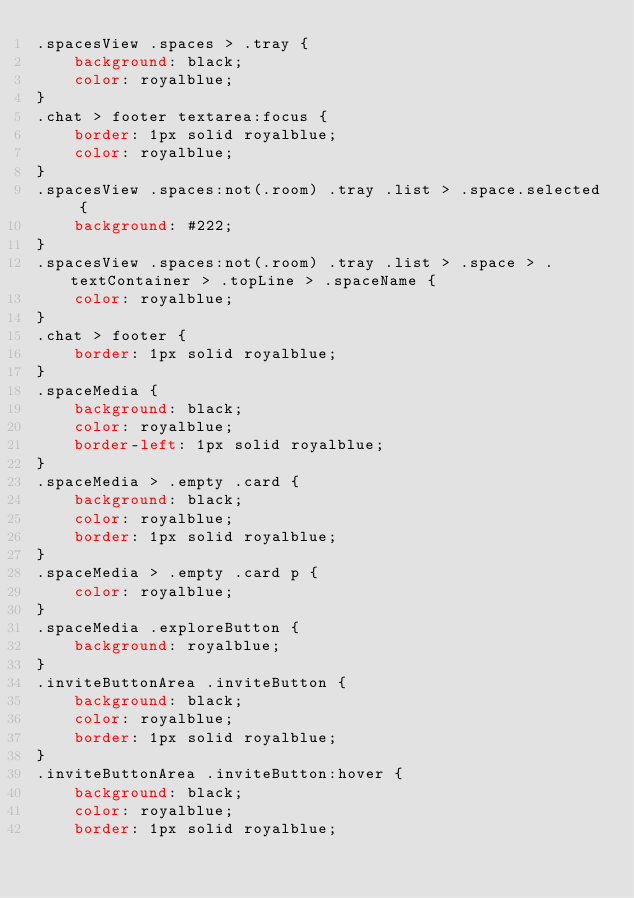Convert code to text. <code><loc_0><loc_0><loc_500><loc_500><_CSS_>.spacesView .spaces > .tray {
    background: black;
    color: royalblue;
}
.chat > footer textarea:focus {
    border: 1px solid royalblue;
    color: royalblue;
}
.spacesView .spaces:not(.room) .tray .list > .space.selected {
    background: #222;
}
.spacesView .spaces:not(.room) .tray .list > .space > .textContainer > .topLine > .spaceName {
    color: royalblue;
}
.chat > footer {
    border: 1px solid royalblue;
}
.spaceMedia {
    background: black;
    color: royalblue;
    border-left: 1px solid royalblue;
}
.spaceMedia > .empty .card {
    background: black;
    color: royalblue;
    border: 1px solid royalblue;
}
.spaceMedia > .empty .card p {
    color: royalblue;
}
.spaceMedia .exploreButton {
    background: royalblue;
}
.inviteButtonArea .inviteButton {
    background: black;
    color: royalblue;
    border: 1px solid royalblue;
}
.inviteButtonArea .inviteButton:hover {
    background: black;
    color: royalblue;
    border: 1px solid royalblue;</code> 